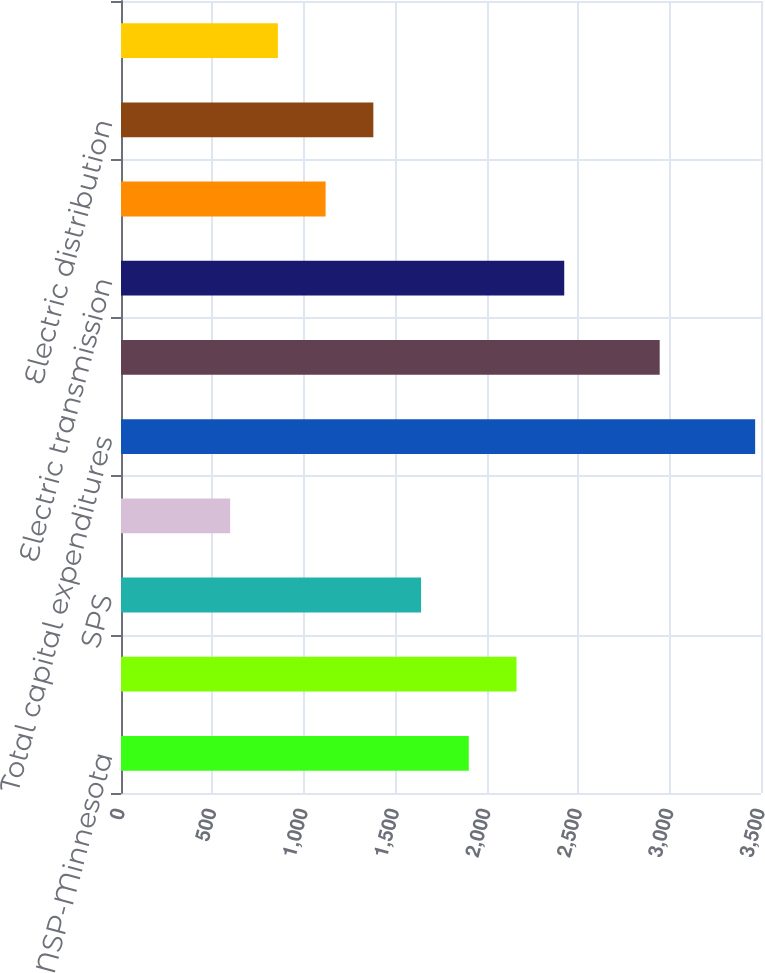<chart> <loc_0><loc_0><loc_500><loc_500><bar_chart><fcel>NSP-Minnesota<fcel>PSCo<fcel>SPS<fcel>NSP-Wisconsin<fcel>Total capital expenditures<fcel>By Function<fcel>Electric transmission<fcel>Electric generation<fcel>Electric distribution<fcel>Natural gas<nl><fcel>1902<fcel>2163<fcel>1641<fcel>597<fcel>3468<fcel>2946<fcel>2424<fcel>1119<fcel>1380<fcel>858<nl></chart> 